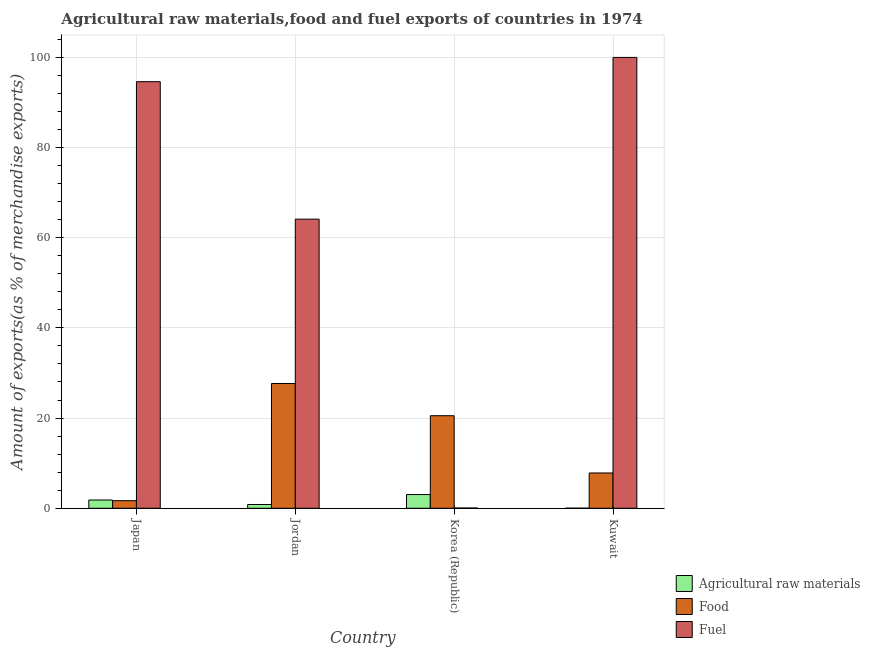Are the number of bars per tick equal to the number of legend labels?
Give a very brief answer. Yes. Are the number of bars on each tick of the X-axis equal?
Your answer should be compact. Yes. What is the label of the 2nd group of bars from the left?
Provide a succinct answer. Jordan. In how many cases, is the number of bars for a given country not equal to the number of legend labels?
Your response must be concise. 0. What is the percentage of raw materials exports in Kuwait?
Keep it short and to the point. 0.02. Across all countries, what is the maximum percentage of raw materials exports?
Give a very brief answer. 3.04. Across all countries, what is the minimum percentage of food exports?
Give a very brief answer. 1.68. In which country was the percentage of food exports maximum?
Your response must be concise. Jordan. In which country was the percentage of food exports minimum?
Offer a very short reply. Japan. What is the total percentage of raw materials exports in the graph?
Keep it short and to the point. 5.73. What is the difference between the percentage of food exports in Jordan and that in Kuwait?
Your answer should be very brief. 19.84. What is the difference between the percentage of fuel exports in Korea (Republic) and the percentage of food exports in Kuwait?
Give a very brief answer. -7.77. What is the average percentage of fuel exports per country?
Keep it short and to the point. 64.68. What is the difference between the percentage of raw materials exports and percentage of food exports in Korea (Republic)?
Keep it short and to the point. -17.48. In how many countries, is the percentage of food exports greater than 12 %?
Provide a succinct answer. 2. What is the ratio of the percentage of raw materials exports in Japan to that in Jordan?
Ensure brevity in your answer.  2.19. Is the percentage of fuel exports in Japan less than that in Jordan?
Your answer should be compact. No. What is the difference between the highest and the second highest percentage of food exports?
Your answer should be very brief. 7.14. What is the difference between the highest and the lowest percentage of food exports?
Your answer should be very brief. 25.98. What does the 3rd bar from the left in Kuwait represents?
Provide a short and direct response. Fuel. What does the 2nd bar from the right in Japan represents?
Your response must be concise. Food. What is the difference between two consecutive major ticks on the Y-axis?
Offer a very short reply. 20. Does the graph contain any zero values?
Ensure brevity in your answer.  No. How are the legend labels stacked?
Keep it short and to the point. Vertical. What is the title of the graph?
Offer a terse response. Agricultural raw materials,food and fuel exports of countries in 1974. What is the label or title of the Y-axis?
Ensure brevity in your answer.  Amount of exports(as % of merchandise exports). What is the Amount of exports(as % of merchandise exports) of Agricultural raw materials in Japan?
Provide a succinct answer. 1.83. What is the Amount of exports(as % of merchandise exports) in Food in Japan?
Your answer should be compact. 1.68. What is the Amount of exports(as % of merchandise exports) in Fuel in Japan?
Provide a short and direct response. 94.59. What is the Amount of exports(as % of merchandise exports) of Agricultural raw materials in Jordan?
Provide a short and direct response. 0.84. What is the Amount of exports(as % of merchandise exports) in Food in Jordan?
Ensure brevity in your answer.  27.67. What is the Amount of exports(as % of merchandise exports) of Fuel in Jordan?
Provide a short and direct response. 64.11. What is the Amount of exports(as % of merchandise exports) in Agricultural raw materials in Korea (Republic)?
Your answer should be very brief. 3.04. What is the Amount of exports(as % of merchandise exports) of Food in Korea (Republic)?
Offer a terse response. 20.52. What is the Amount of exports(as % of merchandise exports) of Fuel in Korea (Republic)?
Offer a terse response. 0.05. What is the Amount of exports(as % of merchandise exports) of Agricultural raw materials in Kuwait?
Your answer should be very brief. 0.02. What is the Amount of exports(as % of merchandise exports) of Food in Kuwait?
Provide a succinct answer. 7.83. What is the Amount of exports(as % of merchandise exports) of Fuel in Kuwait?
Make the answer very short. 99.97. Across all countries, what is the maximum Amount of exports(as % of merchandise exports) in Agricultural raw materials?
Your response must be concise. 3.04. Across all countries, what is the maximum Amount of exports(as % of merchandise exports) of Food?
Your answer should be very brief. 27.67. Across all countries, what is the maximum Amount of exports(as % of merchandise exports) of Fuel?
Offer a terse response. 99.97. Across all countries, what is the minimum Amount of exports(as % of merchandise exports) in Agricultural raw materials?
Offer a very short reply. 0.02. Across all countries, what is the minimum Amount of exports(as % of merchandise exports) of Food?
Your response must be concise. 1.68. Across all countries, what is the minimum Amount of exports(as % of merchandise exports) in Fuel?
Your answer should be very brief. 0.05. What is the total Amount of exports(as % of merchandise exports) of Agricultural raw materials in the graph?
Provide a succinct answer. 5.73. What is the total Amount of exports(as % of merchandise exports) of Food in the graph?
Give a very brief answer. 57.7. What is the total Amount of exports(as % of merchandise exports) of Fuel in the graph?
Provide a succinct answer. 258.72. What is the difference between the Amount of exports(as % of merchandise exports) of Food in Japan and that in Jordan?
Your answer should be very brief. -25.98. What is the difference between the Amount of exports(as % of merchandise exports) in Fuel in Japan and that in Jordan?
Your answer should be compact. 30.48. What is the difference between the Amount of exports(as % of merchandise exports) of Agricultural raw materials in Japan and that in Korea (Republic)?
Make the answer very short. -1.21. What is the difference between the Amount of exports(as % of merchandise exports) of Food in Japan and that in Korea (Republic)?
Provide a succinct answer. -18.84. What is the difference between the Amount of exports(as % of merchandise exports) in Fuel in Japan and that in Korea (Republic)?
Offer a very short reply. 94.54. What is the difference between the Amount of exports(as % of merchandise exports) in Agricultural raw materials in Japan and that in Kuwait?
Provide a short and direct response. 1.81. What is the difference between the Amount of exports(as % of merchandise exports) in Food in Japan and that in Kuwait?
Provide a succinct answer. -6.14. What is the difference between the Amount of exports(as % of merchandise exports) in Fuel in Japan and that in Kuwait?
Ensure brevity in your answer.  -5.38. What is the difference between the Amount of exports(as % of merchandise exports) of Agricultural raw materials in Jordan and that in Korea (Republic)?
Give a very brief answer. -2.2. What is the difference between the Amount of exports(as % of merchandise exports) of Food in Jordan and that in Korea (Republic)?
Keep it short and to the point. 7.14. What is the difference between the Amount of exports(as % of merchandise exports) in Fuel in Jordan and that in Korea (Republic)?
Offer a very short reply. 64.05. What is the difference between the Amount of exports(as % of merchandise exports) in Agricultural raw materials in Jordan and that in Kuwait?
Your response must be concise. 0.82. What is the difference between the Amount of exports(as % of merchandise exports) of Food in Jordan and that in Kuwait?
Your answer should be very brief. 19.84. What is the difference between the Amount of exports(as % of merchandise exports) in Fuel in Jordan and that in Kuwait?
Your answer should be very brief. -35.86. What is the difference between the Amount of exports(as % of merchandise exports) of Agricultural raw materials in Korea (Republic) and that in Kuwait?
Give a very brief answer. 3.02. What is the difference between the Amount of exports(as % of merchandise exports) in Food in Korea (Republic) and that in Kuwait?
Provide a short and direct response. 12.7. What is the difference between the Amount of exports(as % of merchandise exports) in Fuel in Korea (Republic) and that in Kuwait?
Keep it short and to the point. -99.91. What is the difference between the Amount of exports(as % of merchandise exports) in Agricultural raw materials in Japan and the Amount of exports(as % of merchandise exports) in Food in Jordan?
Offer a very short reply. -25.83. What is the difference between the Amount of exports(as % of merchandise exports) of Agricultural raw materials in Japan and the Amount of exports(as % of merchandise exports) of Fuel in Jordan?
Your answer should be compact. -62.27. What is the difference between the Amount of exports(as % of merchandise exports) of Food in Japan and the Amount of exports(as % of merchandise exports) of Fuel in Jordan?
Provide a succinct answer. -62.43. What is the difference between the Amount of exports(as % of merchandise exports) in Agricultural raw materials in Japan and the Amount of exports(as % of merchandise exports) in Food in Korea (Republic)?
Provide a succinct answer. -18.69. What is the difference between the Amount of exports(as % of merchandise exports) of Agricultural raw materials in Japan and the Amount of exports(as % of merchandise exports) of Fuel in Korea (Republic)?
Your answer should be very brief. 1.78. What is the difference between the Amount of exports(as % of merchandise exports) in Food in Japan and the Amount of exports(as % of merchandise exports) in Fuel in Korea (Republic)?
Provide a short and direct response. 1.63. What is the difference between the Amount of exports(as % of merchandise exports) of Agricultural raw materials in Japan and the Amount of exports(as % of merchandise exports) of Food in Kuwait?
Provide a short and direct response. -5.99. What is the difference between the Amount of exports(as % of merchandise exports) of Agricultural raw materials in Japan and the Amount of exports(as % of merchandise exports) of Fuel in Kuwait?
Provide a succinct answer. -98.14. What is the difference between the Amount of exports(as % of merchandise exports) of Food in Japan and the Amount of exports(as % of merchandise exports) of Fuel in Kuwait?
Offer a terse response. -98.29. What is the difference between the Amount of exports(as % of merchandise exports) of Agricultural raw materials in Jordan and the Amount of exports(as % of merchandise exports) of Food in Korea (Republic)?
Ensure brevity in your answer.  -19.68. What is the difference between the Amount of exports(as % of merchandise exports) in Agricultural raw materials in Jordan and the Amount of exports(as % of merchandise exports) in Fuel in Korea (Republic)?
Provide a short and direct response. 0.78. What is the difference between the Amount of exports(as % of merchandise exports) of Food in Jordan and the Amount of exports(as % of merchandise exports) of Fuel in Korea (Republic)?
Provide a succinct answer. 27.61. What is the difference between the Amount of exports(as % of merchandise exports) in Agricultural raw materials in Jordan and the Amount of exports(as % of merchandise exports) in Food in Kuwait?
Provide a succinct answer. -6.99. What is the difference between the Amount of exports(as % of merchandise exports) of Agricultural raw materials in Jordan and the Amount of exports(as % of merchandise exports) of Fuel in Kuwait?
Ensure brevity in your answer.  -99.13. What is the difference between the Amount of exports(as % of merchandise exports) in Food in Jordan and the Amount of exports(as % of merchandise exports) in Fuel in Kuwait?
Offer a terse response. -72.3. What is the difference between the Amount of exports(as % of merchandise exports) of Agricultural raw materials in Korea (Republic) and the Amount of exports(as % of merchandise exports) of Food in Kuwait?
Provide a succinct answer. -4.79. What is the difference between the Amount of exports(as % of merchandise exports) in Agricultural raw materials in Korea (Republic) and the Amount of exports(as % of merchandise exports) in Fuel in Kuwait?
Offer a very short reply. -96.93. What is the difference between the Amount of exports(as % of merchandise exports) of Food in Korea (Republic) and the Amount of exports(as % of merchandise exports) of Fuel in Kuwait?
Offer a terse response. -79.45. What is the average Amount of exports(as % of merchandise exports) of Agricultural raw materials per country?
Provide a succinct answer. 1.43. What is the average Amount of exports(as % of merchandise exports) in Food per country?
Keep it short and to the point. 14.42. What is the average Amount of exports(as % of merchandise exports) in Fuel per country?
Provide a succinct answer. 64.68. What is the difference between the Amount of exports(as % of merchandise exports) in Agricultural raw materials and Amount of exports(as % of merchandise exports) in Food in Japan?
Give a very brief answer. 0.15. What is the difference between the Amount of exports(as % of merchandise exports) of Agricultural raw materials and Amount of exports(as % of merchandise exports) of Fuel in Japan?
Offer a terse response. -92.76. What is the difference between the Amount of exports(as % of merchandise exports) in Food and Amount of exports(as % of merchandise exports) in Fuel in Japan?
Keep it short and to the point. -92.91. What is the difference between the Amount of exports(as % of merchandise exports) of Agricultural raw materials and Amount of exports(as % of merchandise exports) of Food in Jordan?
Give a very brief answer. -26.83. What is the difference between the Amount of exports(as % of merchandise exports) in Agricultural raw materials and Amount of exports(as % of merchandise exports) in Fuel in Jordan?
Offer a terse response. -63.27. What is the difference between the Amount of exports(as % of merchandise exports) of Food and Amount of exports(as % of merchandise exports) of Fuel in Jordan?
Provide a succinct answer. -36.44. What is the difference between the Amount of exports(as % of merchandise exports) of Agricultural raw materials and Amount of exports(as % of merchandise exports) of Food in Korea (Republic)?
Ensure brevity in your answer.  -17.48. What is the difference between the Amount of exports(as % of merchandise exports) of Agricultural raw materials and Amount of exports(as % of merchandise exports) of Fuel in Korea (Republic)?
Your answer should be compact. 2.98. What is the difference between the Amount of exports(as % of merchandise exports) of Food and Amount of exports(as % of merchandise exports) of Fuel in Korea (Republic)?
Keep it short and to the point. 20.47. What is the difference between the Amount of exports(as % of merchandise exports) of Agricultural raw materials and Amount of exports(as % of merchandise exports) of Food in Kuwait?
Offer a very short reply. -7.81. What is the difference between the Amount of exports(as % of merchandise exports) of Agricultural raw materials and Amount of exports(as % of merchandise exports) of Fuel in Kuwait?
Ensure brevity in your answer.  -99.95. What is the difference between the Amount of exports(as % of merchandise exports) of Food and Amount of exports(as % of merchandise exports) of Fuel in Kuwait?
Your response must be concise. -92.14. What is the ratio of the Amount of exports(as % of merchandise exports) of Agricultural raw materials in Japan to that in Jordan?
Ensure brevity in your answer.  2.19. What is the ratio of the Amount of exports(as % of merchandise exports) of Food in Japan to that in Jordan?
Your response must be concise. 0.06. What is the ratio of the Amount of exports(as % of merchandise exports) of Fuel in Japan to that in Jordan?
Give a very brief answer. 1.48. What is the ratio of the Amount of exports(as % of merchandise exports) in Agricultural raw materials in Japan to that in Korea (Republic)?
Keep it short and to the point. 0.6. What is the ratio of the Amount of exports(as % of merchandise exports) of Food in Japan to that in Korea (Republic)?
Offer a terse response. 0.08. What is the ratio of the Amount of exports(as % of merchandise exports) in Fuel in Japan to that in Korea (Republic)?
Your response must be concise. 1738.08. What is the ratio of the Amount of exports(as % of merchandise exports) in Agricultural raw materials in Japan to that in Kuwait?
Your answer should be very brief. 86.26. What is the ratio of the Amount of exports(as % of merchandise exports) of Food in Japan to that in Kuwait?
Provide a succinct answer. 0.21. What is the ratio of the Amount of exports(as % of merchandise exports) of Fuel in Japan to that in Kuwait?
Your response must be concise. 0.95. What is the ratio of the Amount of exports(as % of merchandise exports) in Agricultural raw materials in Jordan to that in Korea (Republic)?
Your response must be concise. 0.28. What is the ratio of the Amount of exports(as % of merchandise exports) of Food in Jordan to that in Korea (Republic)?
Provide a short and direct response. 1.35. What is the ratio of the Amount of exports(as % of merchandise exports) of Fuel in Jordan to that in Korea (Republic)?
Your answer should be compact. 1177.97. What is the ratio of the Amount of exports(as % of merchandise exports) of Agricultural raw materials in Jordan to that in Kuwait?
Offer a very short reply. 39.46. What is the ratio of the Amount of exports(as % of merchandise exports) of Food in Jordan to that in Kuwait?
Make the answer very short. 3.53. What is the ratio of the Amount of exports(as % of merchandise exports) of Fuel in Jordan to that in Kuwait?
Make the answer very short. 0.64. What is the ratio of the Amount of exports(as % of merchandise exports) of Agricultural raw materials in Korea (Republic) to that in Kuwait?
Keep it short and to the point. 143.04. What is the ratio of the Amount of exports(as % of merchandise exports) of Food in Korea (Republic) to that in Kuwait?
Offer a terse response. 2.62. What is the ratio of the Amount of exports(as % of merchandise exports) in Fuel in Korea (Republic) to that in Kuwait?
Offer a very short reply. 0. What is the difference between the highest and the second highest Amount of exports(as % of merchandise exports) of Agricultural raw materials?
Your response must be concise. 1.21. What is the difference between the highest and the second highest Amount of exports(as % of merchandise exports) in Food?
Your answer should be compact. 7.14. What is the difference between the highest and the second highest Amount of exports(as % of merchandise exports) in Fuel?
Offer a terse response. 5.38. What is the difference between the highest and the lowest Amount of exports(as % of merchandise exports) of Agricultural raw materials?
Keep it short and to the point. 3.02. What is the difference between the highest and the lowest Amount of exports(as % of merchandise exports) in Food?
Make the answer very short. 25.98. What is the difference between the highest and the lowest Amount of exports(as % of merchandise exports) of Fuel?
Keep it short and to the point. 99.91. 